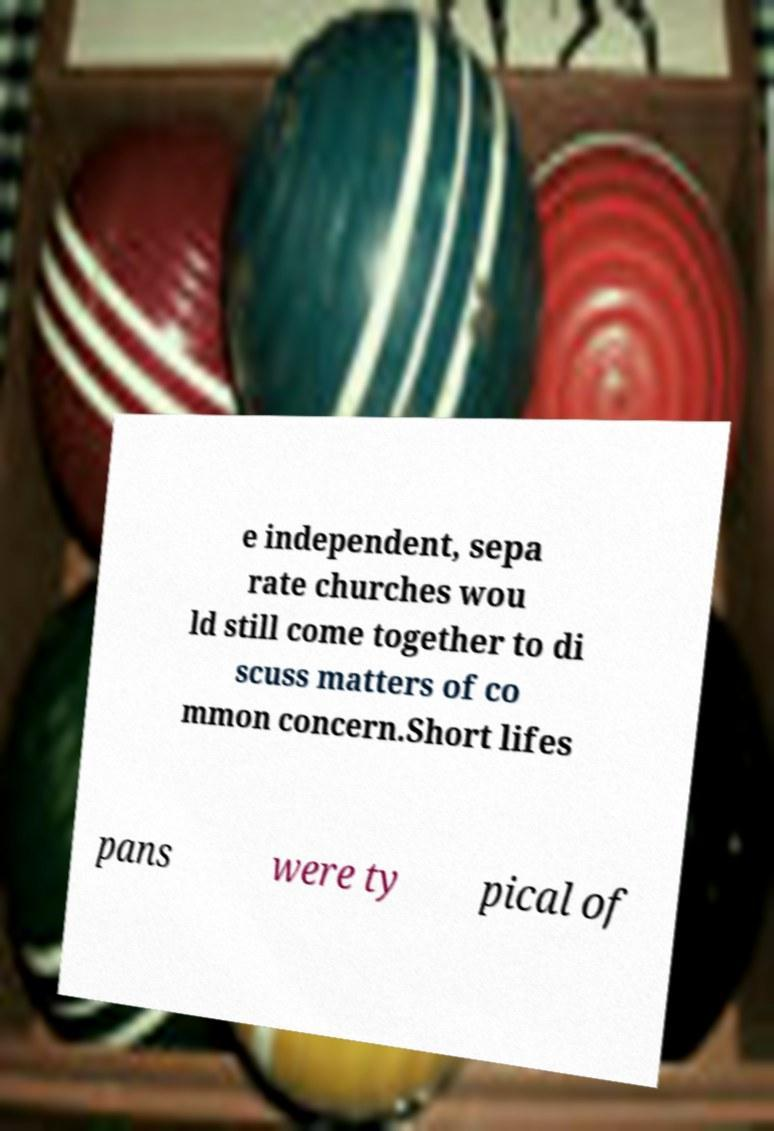What messages or text are displayed in this image? I need them in a readable, typed format. e independent, sepa rate churches wou ld still come together to di scuss matters of co mmon concern.Short lifes pans were ty pical of 